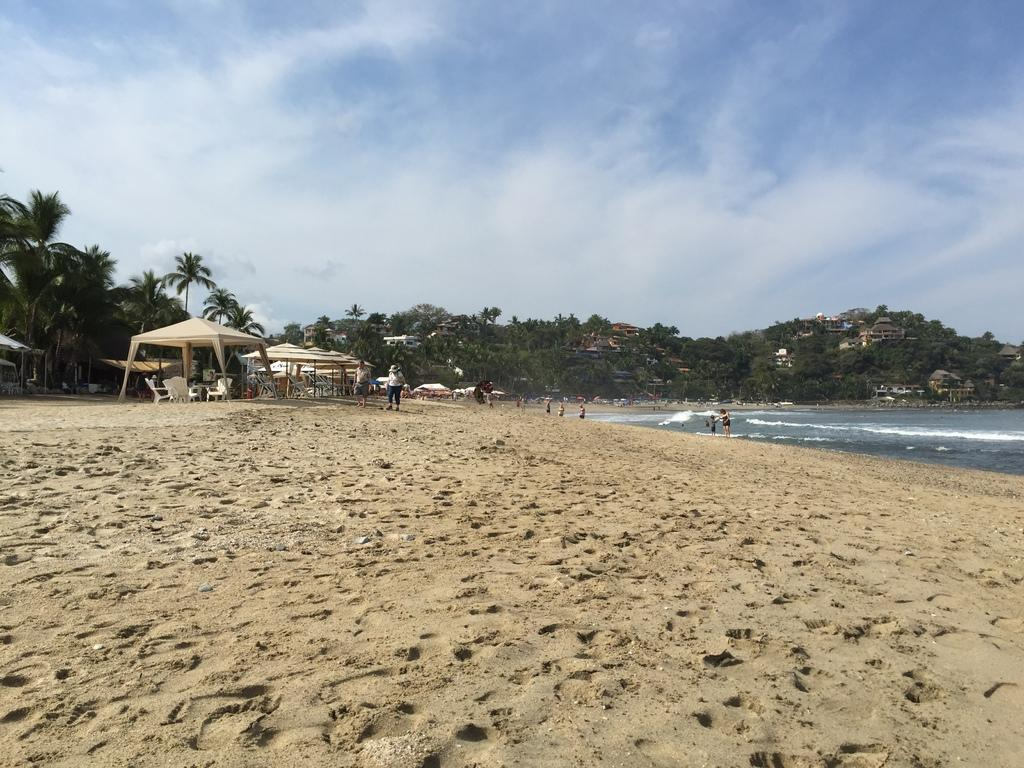What type of structures can be seen in the image? There are huts, buildings, and tables in the image. What type of furniture is present in the image? There are chairs in the image. Who or what is present in the image? There are people in the image. What type of natural environment is visible in the image? There are trees and water visible in the image. What type of terrain is present in the image? There is sand in the image. What is visible in the background of the image? The sky is visible in the background of the image. What type of theory is being discussed by the people in the image? There is no indication in the image that a theory is being discussed. What color is the hat worn by the person in the image? There is no hat visible in the image. What type of experience can be gained by visiting the location in the image? The image does not provide enough information to determine the type of experience that can be gained by visiting the location. 